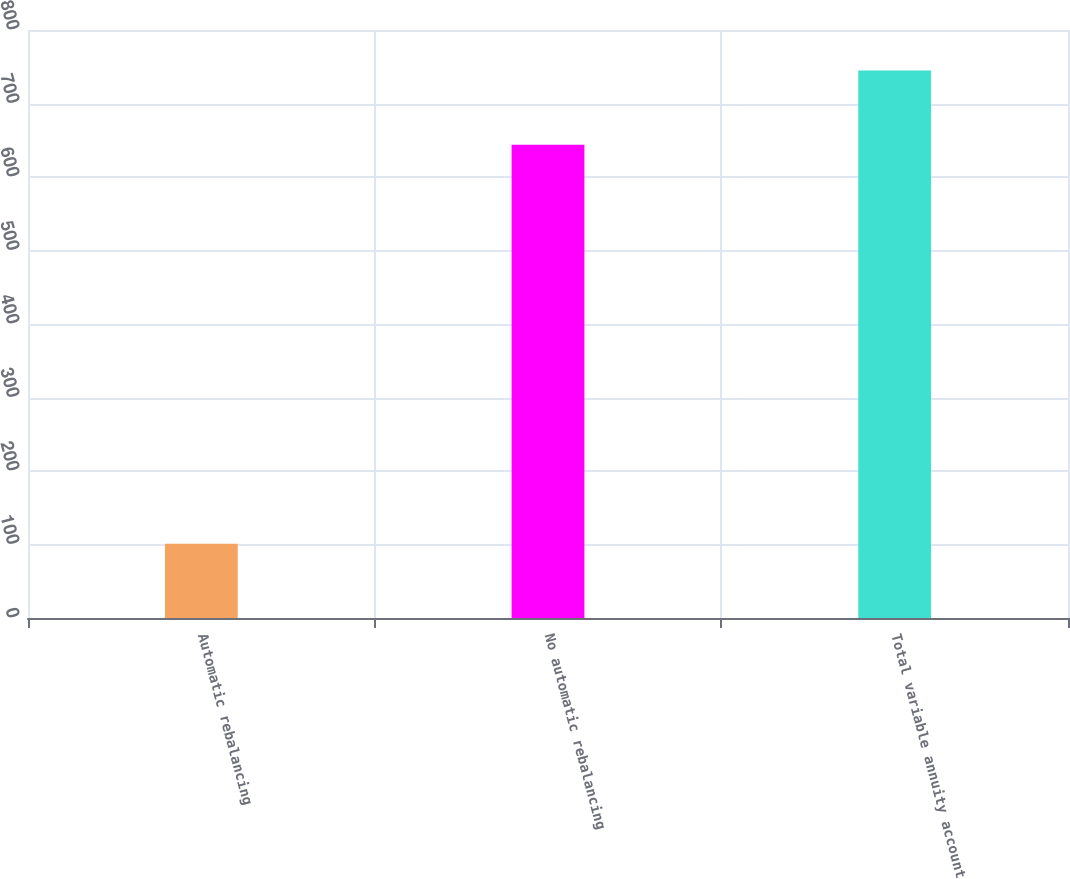<chart> <loc_0><loc_0><loc_500><loc_500><bar_chart><fcel>Automatic rebalancing<fcel>No automatic rebalancing<fcel>Total variable annuity account<nl><fcel>101<fcel>644<fcel>745<nl></chart> 